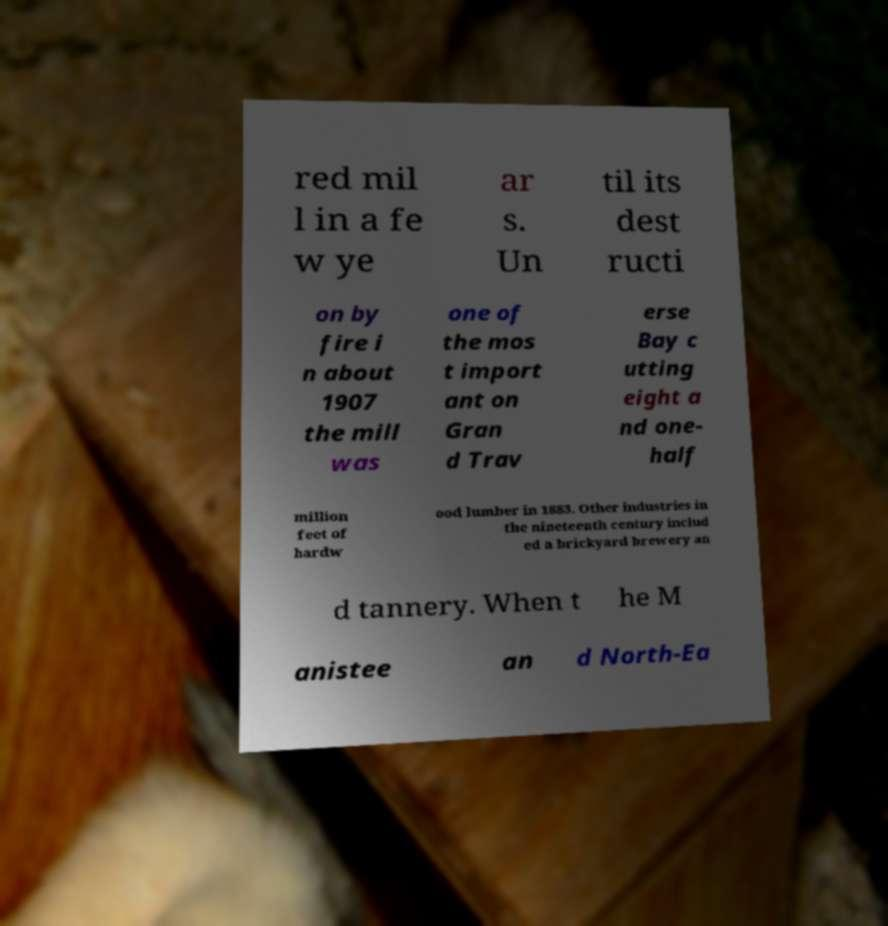There's text embedded in this image that I need extracted. Can you transcribe it verbatim? red mil l in a fe w ye ar s. Un til its dest ructi on by fire i n about 1907 the mill was one of the mos t import ant on Gran d Trav erse Bay c utting eight a nd one- half million feet of hardw ood lumber in 1883. Other industries in the nineteenth century includ ed a brickyard brewery an d tannery. When t he M anistee an d North-Ea 